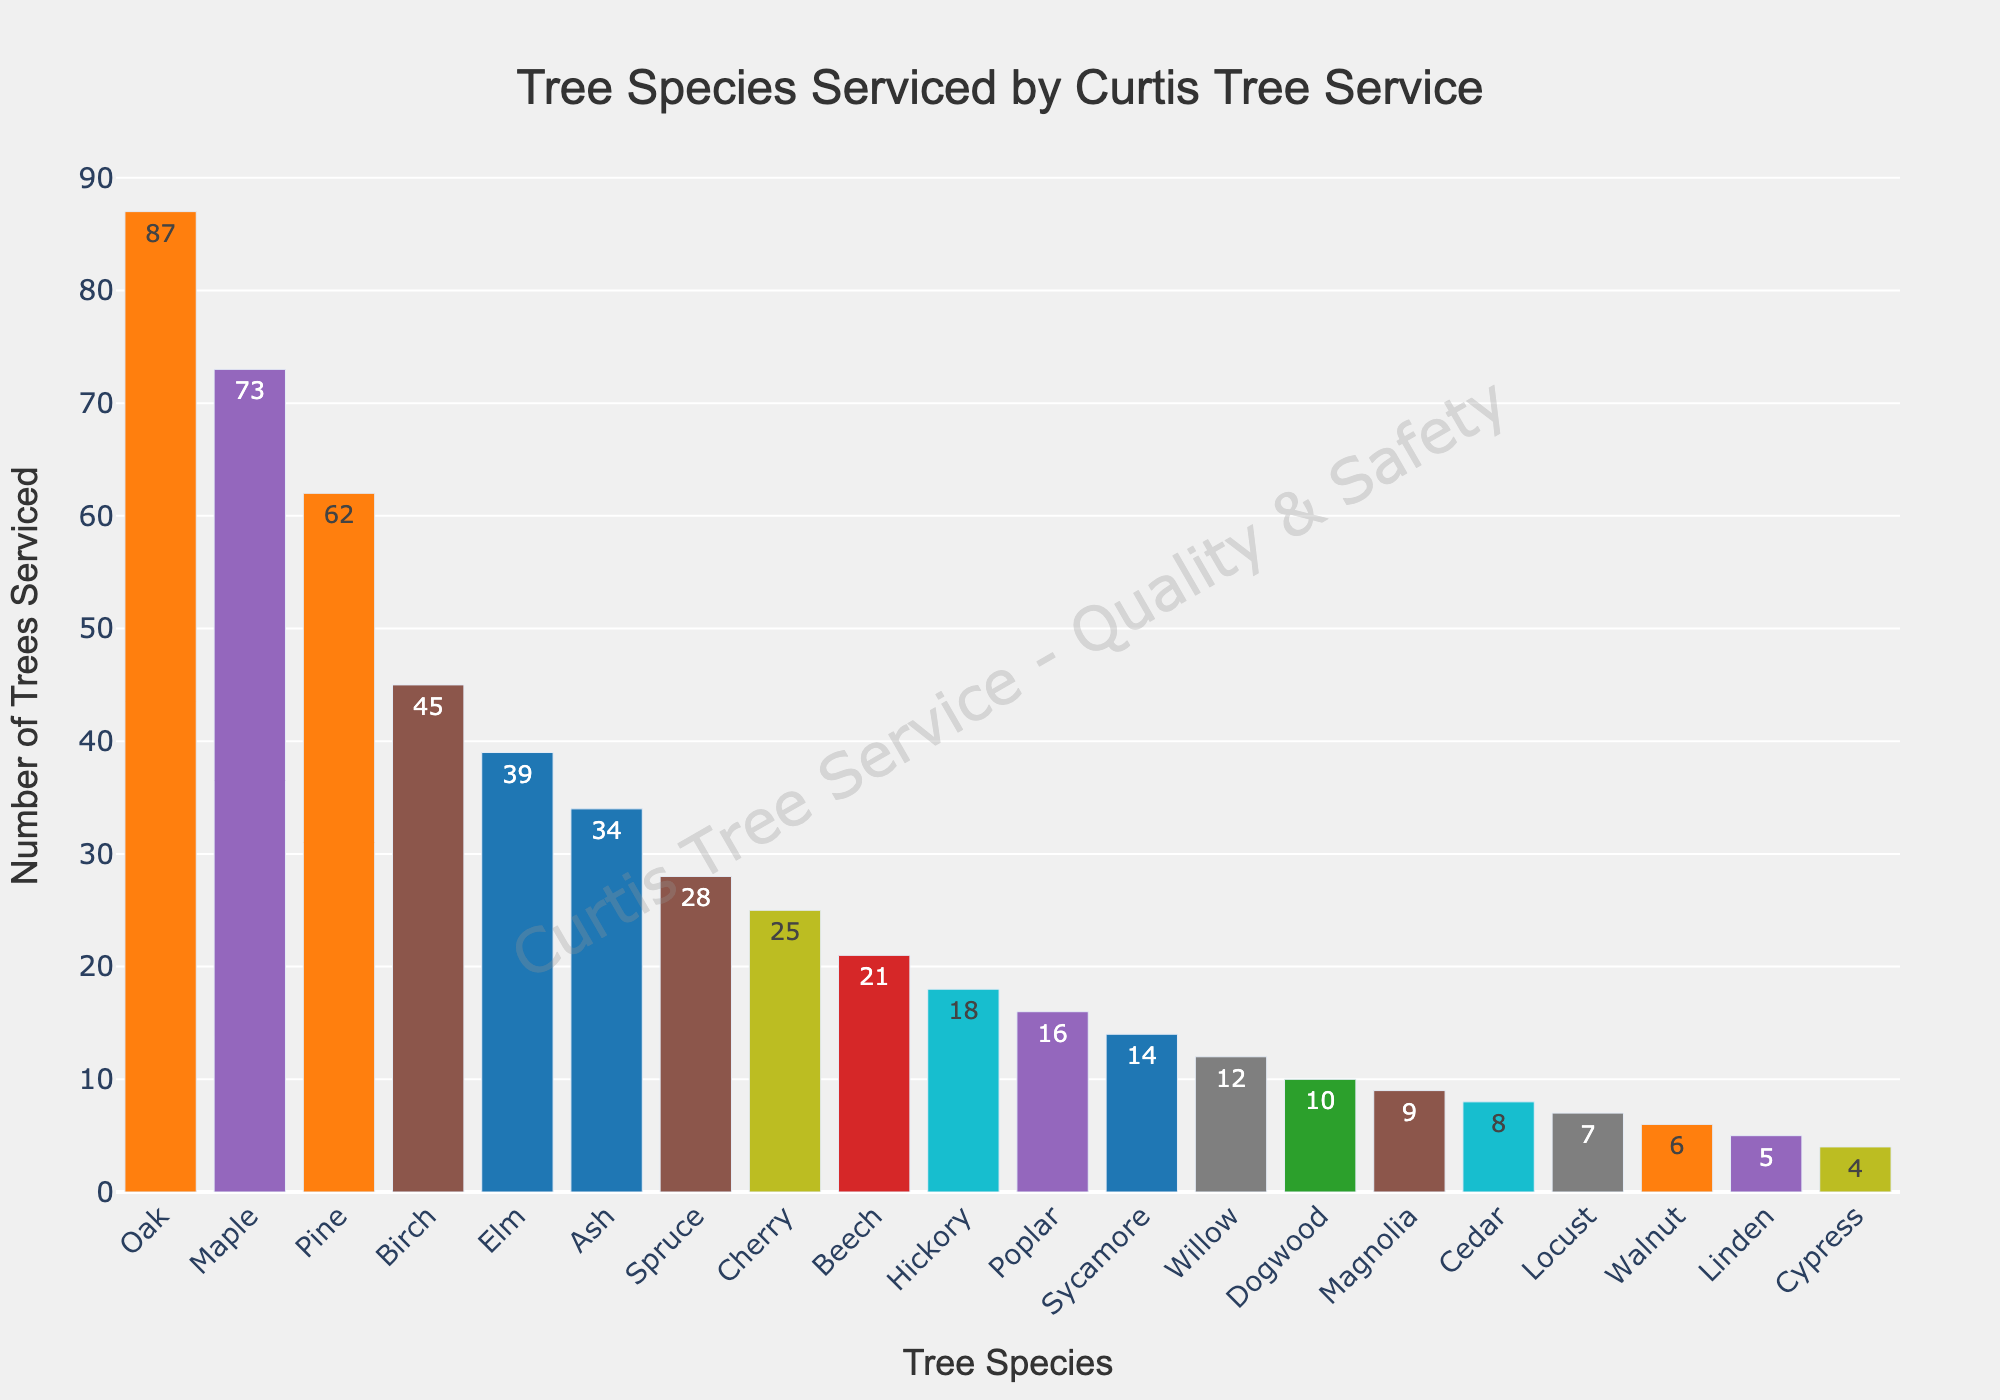Which tree species was serviced the most by Curtis Tree Service? The bar chart shows that the species with the highest number of trees serviced is Oak.
Answer: Oak Which tree species was serviced the least by Curtis Tree Service? The bar chart shows that the species with the lowest number of trees serviced is Cypress.
Answer: Cypress How many more Oak trees were serviced compared to Dogwood trees? The number of Oak trees serviced is 87, and the number of Dogwood trees is 10. The difference is 87 - 10 = 77.
Answer: 77 What is the total number of Maple and Pine trees serviced? The number of Maple trees serviced is 73, and the number of Pine trees is 62. The total is 73 + 62 = 135.
Answer: 135 Which tree species is serviced more, Elm or Cedar? The number of Elm trees serviced is 39, while the number of Cedar trees is 8. 39 is greater than 8, so Elm trees are serviced more.
Answer: Elm How many tree species have been serviced at least 20 times? From the bar chart, the species serviced at least 20 times are Oak (87), Maple (73), Pine (62), Birch (45), Elm (39), Ash (34), Spruce (28), Cherry (25), and Beech (21). There are 9 such species.
Answer: 9 Is the number of Beech trees serviced greater than the number of Hickory trees serviced? The number of Beech trees serviced is 21, and the number of Hickory trees serviced is 18. Since 21 is greater than 18, the number of Beech trees serviced is greater.
Answer: Yes Which species serviced have counts between 10 and 30? The species with counts between 10 and 30 are Spruce (28), Cherry (25), Beech (21), Hickory (18), Poplar (16), Sycamore (14), Willow (12).
Answer: Spruce, Cherry, Beech, Hickory, Poplar, Sycamore, Willow What is the average number of trees serviced across all species? The sum of all counts is 87+73+62+45+39+34+28+25+21+18+16+14+12+10+9+8+7+6+5+4 = 523. There are 20 species, so the average is 523 / 20 = 26.15.
Answer: 26.15 Which three species have been serviced the most? The three species with the highest counts are Oak (87), Maple (73), and Pine (62).
Answer: Oak, Maple, Pine 